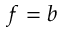<formula> <loc_0><loc_0><loc_500><loc_500>f = b</formula> 